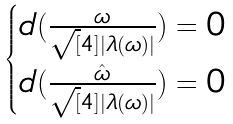<formula> <loc_0><loc_0><loc_500><loc_500>\begin{cases} d ( \frac { \omega } { \sqrt { [ } 4 ] { | \lambda ( \omega ) | } } ) = 0 & \\ d ( \frac { \hat { \omega } } { \sqrt { [ } 4 ] { | \lambda ( \omega ) | } } ) = 0 & \\ \end{cases}</formula> 